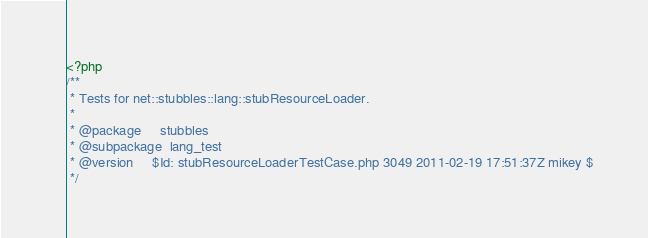<code> <loc_0><loc_0><loc_500><loc_500><_PHP_><?php
/**
 * Tests for net::stubbles::lang::stubResourceLoader.
 *
 * @package     stubbles
 * @subpackage  lang_test
 * @version     $Id: stubResourceLoaderTestCase.php 3049 2011-02-19 17:51:37Z mikey $
 */</code> 